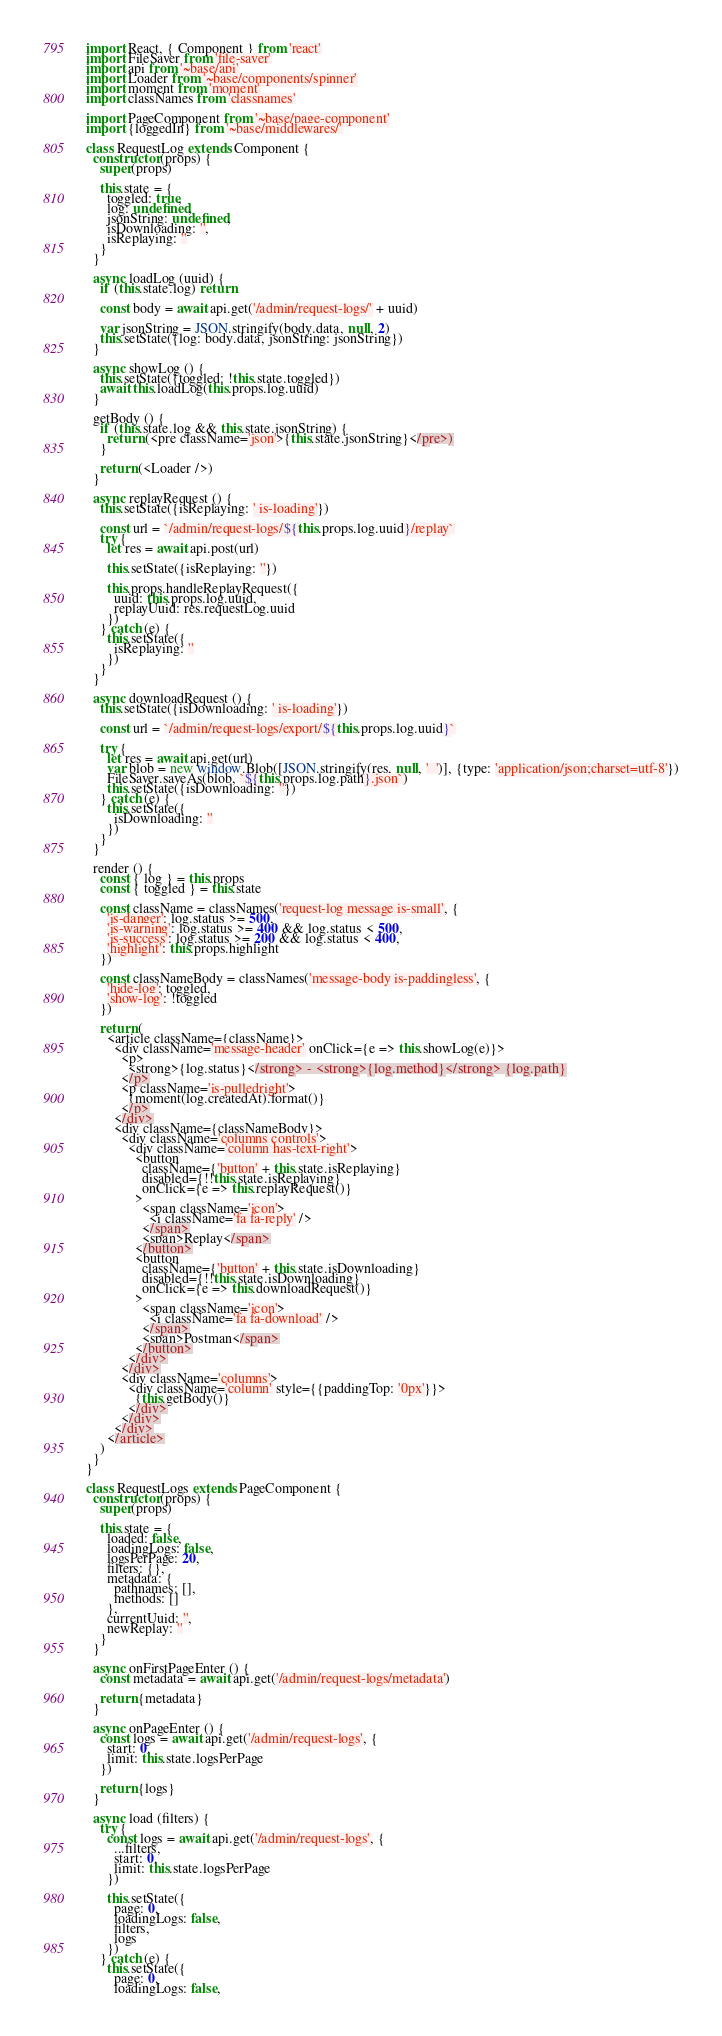<code> <loc_0><loc_0><loc_500><loc_500><_JavaScript_>import React, { Component } from 'react'
import FileSaver from 'file-saver'
import api from '~base/api'
import Loader from '~base/components/spinner'
import moment from 'moment'
import classNames from 'classnames'

import PageComponent from '~base/page-component'
import {loggedIn} from '~base/middlewares/'

class RequestLog extends Component {
  constructor (props) {
    super(props)

    this.state = {
      toggled: true,
      log: undefined,
      jsonString: undefined,
      isDownloading: '',
      isReplaying: ''
    }
  }

  async loadLog (uuid) {
    if (this.state.log) return

    const body = await api.get('/admin/request-logs/' + uuid)

    var jsonString = JSON.stringify(body.data, null, 2)
    this.setState({log: body.data, jsonString: jsonString})
  }

  async showLog () {
    this.setState({toggled: !this.state.toggled})
    await this.loadLog(this.props.log.uuid)
  }

  getBody () {
    if (this.state.log && this.state.jsonString) {
      return (<pre className='json'>{this.state.jsonString}</pre>)
    }

    return (<Loader />)
  }

  async replayRequest () {
    this.setState({isReplaying: ' is-loading'})

    const url = `/admin/request-logs/${this.props.log.uuid}/replay`
    try {
      let res = await api.post(url)

      this.setState({isReplaying: ''})

      this.props.handleReplayRequest({
        uuid: this.props.log.uuid,
        replayUuid: res.requestLog.uuid
      })
    } catch (e) {
      this.setState({
        isReplaying: ''
      })
    }
  }

  async downloadRequest () {
    this.setState({isDownloading: ' is-loading'})

    const url = `/admin/request-logs/export/${this.props.log.uuid}`

    try {
      let res = await api.get(url)
      var blob = new window.Blob([JSON.stringify(res, null, '  ')], {type: 'application/json;charset=utf-8'})
      FileSaver.saveAs(blob, `${this.props.log.path}.json`)
      this.setState({isDownloading: ''})
    } catch (e) {
      this.setState({
        isDownloading: ''
      })
    }
  }

  render () {
    const { log } = this.props
    const { toggled } = this.state

    const className = classNames('request-log message is-small', {
      'is-danger': log.status >= 500,
      'is-warning': log.status >= 400 && log.status < 500,
      'is-success': log.status >= 200 && log.status < 400,
      'highlight': this.props.highlight
    })

    const classNameBody = classNames('message-body is-paddingless', {
      'hide-log': toggled,
      'show-log': !toggled
    })

    return (
      <article className={className}>
        <div className='message-header' onClick={e => this.showLog(e)}>
          <p>
            <strong>{log.status}</strong> - <strong>{log.method}</strong> {log.path}
          </p>
          <p className='is-pulledright'>
            {moment(log.createdAt).format()}
          </p>
        </div>
        <div className={classNameBody}>
          <div className='columns controls'>
            <div className='column has-text-right'>
              <button
                className={'button' + this.state.isReplaying}
                disabled={!!this.state.isReplaying}
                onClick={e => this.replayRequest()}
              >
                <span className='icon'>
                  <i className='fa fa-reply' />
                </span>
                <span>Replay</span>
              </button>
              <button
                className={'button' + this.state.isDownloading}
                disabled={!!this.state.isDownloading}
                onClick={e => this.downloadRequest()}
              >
                <span className='icon'>
                  <i className='fa fa-download' />
                </span>
                <span>Postman</span>
              </button>
            </div>
          </div>
          <div className='columns'>
            <div className='column' style={{paddingTop: '0px'}}>
              {this.getBody()}
            </div>
          </div>
        </div>
      </article>
    )
  }
}

class RequestLogs extends PageComponent {
  constructor (props) {
    super(props)

    this.state = {
      loaded: false,
      loadingLogs: false,
      logsPerPage: 20,
      filters: {},
      metadata: {
        pathnames: [],
        methods: []
      },
      currentUuid: '',
      newReplay: ''
    }
  }

  async onFirstPageEnter () {
    const metadata = await api.get('/admin/request-logs/metadata')

    return {metadata}
  }

  async onPageEnter () {
    const logs = await api.get('/admin/request-logs', {
      start: 0,
      limit: this.state.logsPerPage
    })

    return {logs}
  }

  async load (filters) {
    try {
      const logs = await api.get('/admin/request-logs', {
        ...filters,
        start: 0,
        limit: this.state.logsPerPage
      })

      this.setState({
        page: 0,
        loadingLogs: false,
        filters,
        logs
      })
    } catch (e) {
      this.setState({
        page: 0,
        loadingLogs: false,</code> 